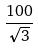<formula> <loc_0><loc_0><loc_500><loc_500>\frac { 1 0 0 } { \sqrt { 3 } }</formula> 